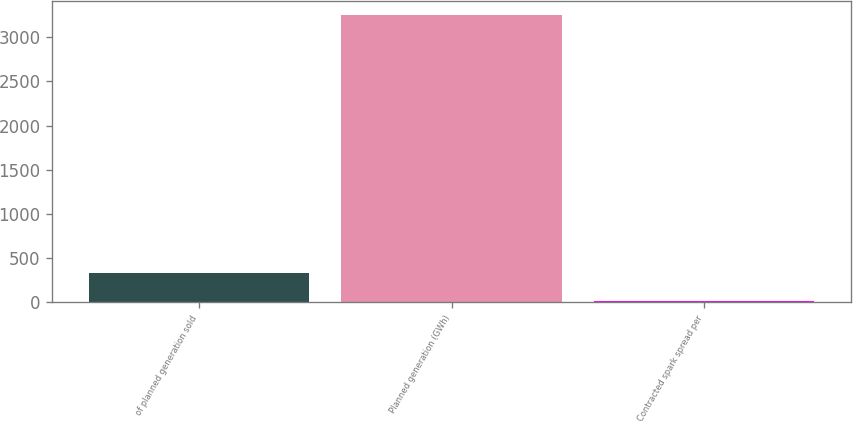<chart> <loc_0><loc_0><loc_500><loc_500><bar_chart><fcel>of planned generation sold<fcel>Planned generation (GWh)<fcel>Contracted spark spread per<nl><fcel>334.47<fcel>3249<fcel>10.63<nl></chart> 